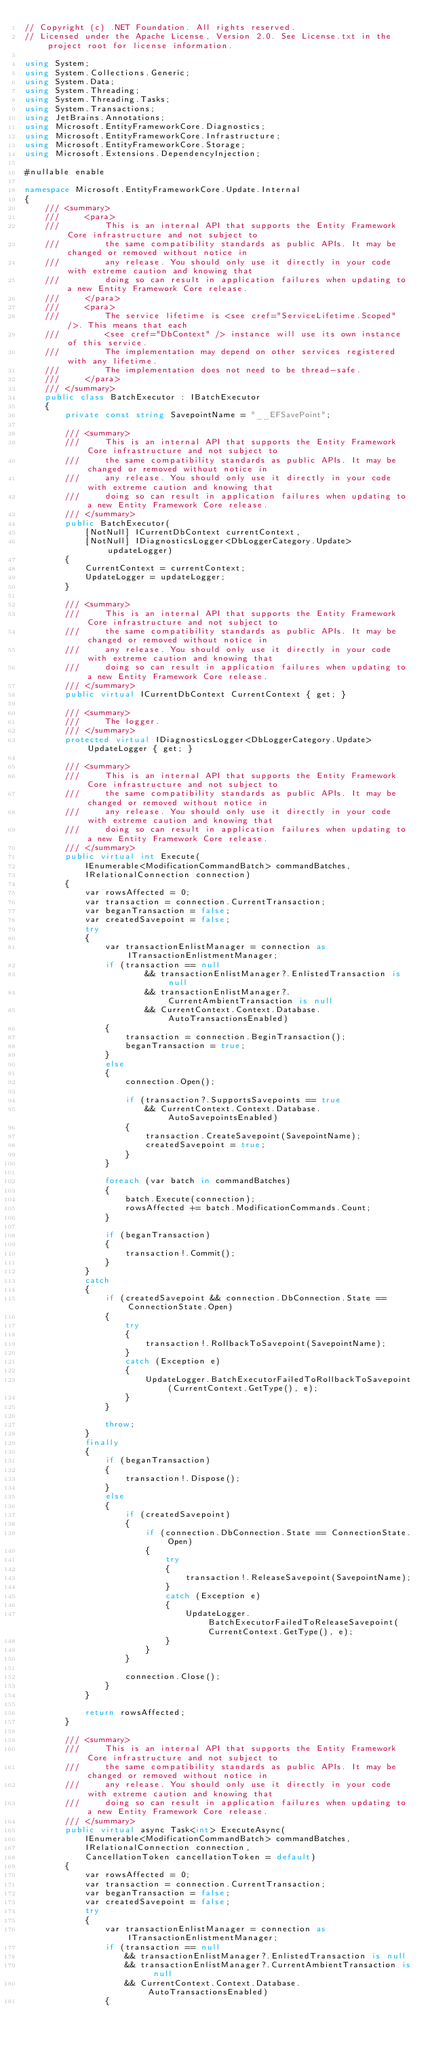Convert code to text. <code><loc_0><loc_0><loc_500><loc_500><_C#_>// Copyright (c) .NET Foundation. All rights reserved.
// Licensed under the Apache License, Version 2.0. See License.txt in the project root for license information.

using System;
using System.Collections.Generic;
using System.Data;
using System.Threading;
using System.Threading.Tasks;
using System.Transactions;
using JetBrains.Annotations;
using Microsoft.EntityFrameworkCore.Diagnostics;
using Microsoft.EntityFrameworkCore.Infrastructure;
using Microsoft.EntityFrameworkCore.Storage;
using Microsoft.Extensions.DependencyInjection;

#nullable enable

namespace Microsoft.EntityFrameworkCore.Update.Internal
{
    /// <summary>
    ///     <para>
    ///         This is an internal API that supports the Entity Framework Core infrastructure and not subject to
    ///         the same compatibility standards as public APIs. It may be changed or removed without notice in
    ///         any release. You should only use it directly in your code with extreme caution and knowing that
    ///         doing so can result in application failures when updating to a new Entity Framework Core release.
    ///     </para>
    ///     <para>
    ///         The service lifetime is <see cref="ServiceLifetime.Scoped" />. This means that each
    ///         <see cref="DbContext" /> instance will use its own instance of this service.
    ///         The implementation may depend on other services registered with any lifetime.
    ///         The implementation does not need to be thread-safe.
    ///     </para>
    /// </summary>
    public class BatchExecutor : IBatchExecutor
    {
        private const string SavepointName = "__EFSavePoint";

        /// <summary>
        ///     This is an internal API that supports the Entity Framework Core infrastructure and not subject to
        ///     the same compatibility standards as public APIs. It may be changed or removed without notice in
        ///     any release. You should only use it directly in your code with extreme caution and knowing that
        ///     doing so can result in application failures when updating to a new Entity Framework Core release.
        /// </summary>
        public BatchExecutor(
            [NotNull] ICurrentDbContext currentContext,
            [NotNull] IDiagnosticsLogger<DbLoggerCategory.Update> updateLogger)
        {
            CurrentContext = currentContext;
            UpdateLogger = updateLogger;
        }

        /// <summary>
        ///     This is an internal API that supports the Entity Framework Core infrastructure and not subject to
        ///     the same compatibility standards as public APIs. It may be changed or removed without notice in
        ///     any release. You should only use it directly in your code with extreme caution and knowing that
        ///     doing so can result in application failures when updating to a new Entity Framework Core release.
        /// </summary>
        public virtual ICurrentDbContext CurrentContext { get; }

        /// <summary>
        ///     The logger.
        /// </summary>
        protected virtual IDiagnosticsLogger<DbLoggerCategory.Update> UpdateLogger { get; }

        /// <summary>
        ///     This is an internal API that supports the Entity Framework Core infrastructure and not subject to
        ///     the same compatibility standards as public APIs. It may be changed or removed without notice in
        ///     any release. You should only use it directly in your code with extreme caution and knowing that
        ///     doing so can result in application failures when updating to a new Entity Framework Core release.
        /// </summary>
        public virtual int Execute(
            IEnumerable<ModificationCommandBatch> commandBatches,
            IRelationalConnection connection)
        {
            var rowsAffected = 0;
            var transaction = connection.CurrentTransaction;
            var beganTransaction = false;
            var createdSavepoint = false;
            try
            {
                var transactionEnlistManager = connection as ITransactionEnlistmentManager;
                if (transaction == null
                        && transactionEnlistManager?.EnlistedTransaction is null
                        && transactionEnlistManager?.CurrentAmbientTransaction is null
                        && CurrentContext.Context.Database.AutoTransactionsEnabled)
                {
                    transaction = connection.BeginTransaction();
                    beganTransaction = true;
                }
                else
                {
                    connection.Open();

                    if (transaction?.SupportsSavepoints == true
                        && CurrentContext.Context.Database.AutoSavepointsEnabled)
                    {
                        transaction.CreateSavepoint(SavepointName);
                        createdSavepoint = true;
                    }
                }

                foreach (var batch in commandBatches)
                {
                    batch.Execute(connection);
                    rowsAffected += batch.ModificationCommands.Count;
                }

                if (beganTransaction)
                {
                    transaction!.Commit();
                }
            }
            catch
            {
                if (createdSavepoint && connection.DbConnection.State == ConnectionState.Open)
                {
                    try
                    {
                        transaction!.RollbackToSavepoint(SavepointName);
                    }
                    catch (Exception e)
                    {
                        UpdateLogger.BatchExecutorFailedToRollbackToSavepoint(CurrentContext.GetType(), e);
                    }
                }

                throw;
            }
            finally
            {
                if (beganTransaction)
                {
                    transaction!.Dispose();
                }
                else
                {
                    if (createdSavepoint)
                    {
                        if (connection.DbConnection.State == ConnectionState.Open)
                        {
                            try
                            {
                                transaction!.ReleaseSavepoint(SavepointName);
                            }
                            catch (Exception e)
                            {
                                UpdateLogger.BatchExecutorFailedToReleaseSavepoint(CurrentContext.GetType(), e);
                            }
                        }
                    }

                    connection.Close();
                }
            }

            return rowsAffected;
        }

        /// <summary>
        ///     This is an internal API that supports the Entity Framework Core infrastructure and not subject to
        ///     the same compatibility standards as public APIs. It may be changed or removed without notice in
        ///     any release. You should only use it directly in your code with extreme caution and knowing that
        ///     doing so can result in application failures when updating to a new Entity Framework Core release.
        /// </summary>
        public virtual async Task<int> ExecuteAsync(
            IEnumerable<ModificationCommandBatch> commandBatches,
            IRelationalConnection connection,
            CancellationToken cancellationToken = default)
        {
            var rowsAffected = 0;
            var transaction = connection.CurrentTransaction;
            var beganTransaction = false;
            var createdSavepoint = false;
            try
            {
                var transactionEnlistManager = connection as ITransactionEnlistmentManager;
                if (transaction == null
                    && transactionEnlistManager?.EnlistedTransaction is null
                    && transactionEnlistManager?.CurrentAmbientTransaction is null
                    && CurrentContext.Context.Database.AutoTransactionsEnabled)
                {</code> 